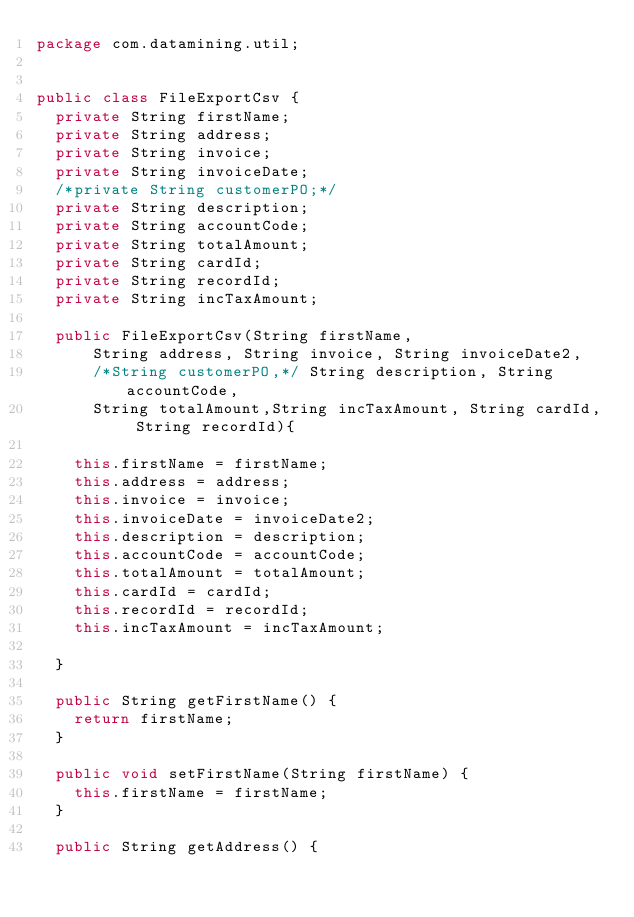<code> <loc_0><loc_0><loc_500><loc_500><_Java_>package com.datamining.util;


public class FileExportCsv {
	private String firstName;
	private String address;
	private String invoice;
	private String invoiceDate;
	/*private String customerPO;*/
	private String description;
	private String accountCode;
	private String totalAmount;
	private String cardId;
	private String recordId;
	private String incTaxAmount;
	
	public FileExportCsv(String firstName, 
			String address, String invoice, String invoiceDate2, 
			/*String customerPO,*/ String description, String accountCode, 
			String totalAmount,String incTaxAmount, String cardId, String recordId){
		
		this.firstName = firstName;
		this.address = address;
		this.invoice = invoice;
		this.invoiceDate = invoiceDate2;
		this.description = description;
		this.accountCode = accountCode;
		this.totalAmount = totalAmount;
		this.cardId = cardId;
		this.recordId = recordId;
		this.incTaxAmount = incTaxAmount;
		
	}

	public String getFirstName() {
		return firstName;
	}

	public void setFirstName(String firstName) {
		this.firstName = firstName;
	}

	public String getAddress() {</code> 